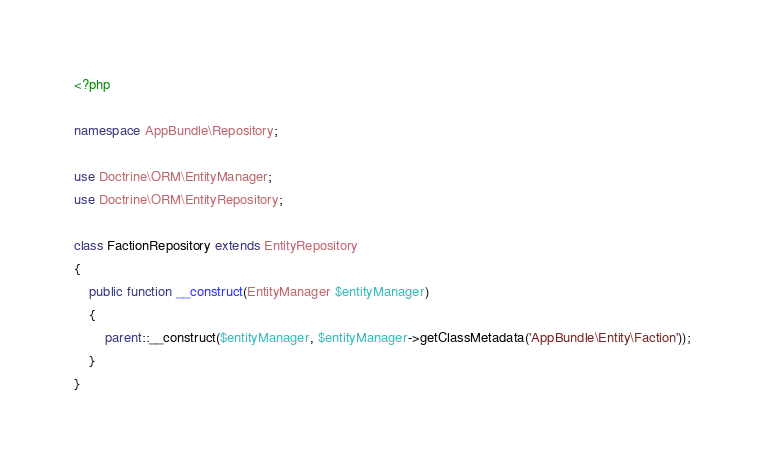<code> <loc_0><loc_0><loc_500><loc_500><_PHP_><?php 

namespace AppBundle\Repository;

use Doctrine\ORM\EntityManager;
use Doctrine\ORM\EntityRepository;

class FactionRepository extends EntityRepository
{
    public function __construct(EntityManager $entityManager)
    {
        parent::__construct($entityManager, $entityManager->getClassMetadata('AppBundle\Entity\Faction'));
    }
}
</code> 